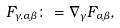<formula> <loc_0><loc_0><loc_500><loc_500>F _ { \gamma , \alpha \beta } \colon = \nabla _ { \gamma } F _ { \alpha \beta } ,</formula> 